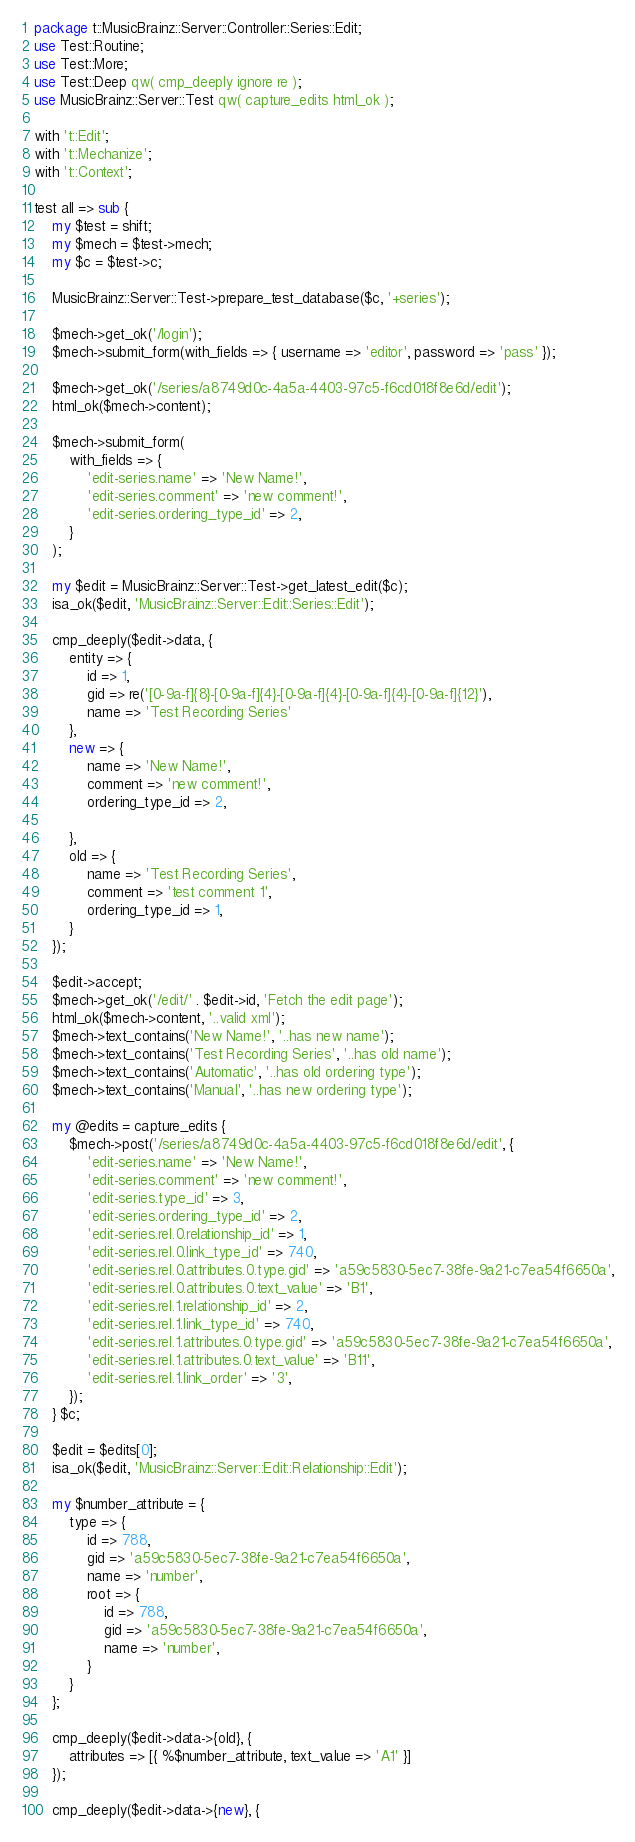<code> <loc_0><loc_0><loc_500><loc_500><_Perl_>package t::MusicBrainz::Server::Controller::Series::Edit;
use Test::Routine;
use Test::More;
use Test::Deep qw( cmp_deeply ignore re );
use MusicBrainz::Server::Test qw( capture_edits html_ok );

with 't::Edit';
with 't::Mechanize';
with 't::Context';

test all => sub {
    my $test = shift;
    my $mech = $test->mech;
    my $c = $test->c;

    MusicBrainz::Server::Test->prepare_test_database($c, '+series');

    $mech->get_ok('/login');
    $mech->submit_form(with_fields => { username => 'editor', password => 'pass' });

    $mech->get_ok('/series/a8749d0c-4a5a-4403-97c5-f6cd018f8e6d/edit');
    html_ok($mech->content);

    $mech->submit_form(
        with_fields => {
            'edit-series.name' => 'New Name!',
            'edit-series.comment' => 'new comment!',
            'edit-series.ordering_type_id' => 2,
        }
    );

    my $edit = MusicBrainz::Server::Test->get_latest_edit($c);
    isa_ok($edit, 'MusicBrainz::Server::Edit::Series::Edit');

    cmp_deeply($edit->data, {
        entity => {
            id => 1,
            gid => re('[0-9a-f]{8}-[0-9a-f]{4}-[0-9a-f]{4}-[0-9a-f]{4}-[0-9a-f]{12}'),
            name => 'Test Recording Series'
        },
        new => {
            name => 'New Name!',
            comment => 'new comment!',
            ordering_type_id => 2,

        },
        old => {
            name => 'Test Recording Series',
            comment => 'test comment 1',
            ordering_type_id => 1,
        }
    });

    $edit->accept;
    $mech->get_ok('/edit/' . $edit->id, 'Fetch the edit page');
    html_ok($mech->content, '..valid xml');
    $mech->text_contains('New Name!', '..has new name');
    $mech->text_contains('Test Recording Series', '..has old name');
    $mech->text_contains('Automatic', '..has old ordering type');
    $mech->text_contains('Manual', '..has new ordering type');

    my @edits = capture_edits {
        $mech->post('/series/a8749d0c-4a5a-4403-97c5-f6cd018f8e6d/edit', {
            'edit-series.name' => 'New Name!',
            'edit-series.comment' => 'new comment!',
            'edit-series.type_id' => 3,
            'edit-series.ordering_type_id' => 2,
            'edit-series.rel.0.relationship_id' => 1,
            'edit-series.rel.0.link_type_id' => 740,
            'edit-series.rel.0.attributes.0.type.gid' => 'a59c5830-5ec7-38fe-9a21-c7ea54f6650a',
            'edit-series.rel.0.attributes.0.text_value' => 'B1',
            'edit-series.rel.1.relationship_id' => 2,
            'edit-series.rel.1.link_type_id' => 740,
            'edit-series.rel.1.attributes.0.type.gid' => 'a59c5830-5ec7-38fe-9a21-c7ea54f6650a',
            'edit-series.rel.1.attributes.0.text_value' => 'B11',
            'edit-series.rel.1.link_order' => '3',
        });
    } $c;

    $edit = $edits[0];
    isa_ok($edit, 'MusicBrainz::Server::Edit::Relationship::Edit');

    my $number_attribute = {
        type => {
            id => 788,
            gid => 'a59c5830-5ec7-38fe-9a21-c7ea54f6650a',
            name => 'number',
            root => {
                id => 788,
                gid => 'a59c5830-5ec7-38fe-9a21-c7ea54f6650a',
                name => 'number',
            }
        }
    };

    cmp_deeply($edit->data->{old}, {
        attributes => [{ %$number_attribute, text_value => 'A1' }]
    });

    cmp_deeply($edit->data->{new}, {</code> 